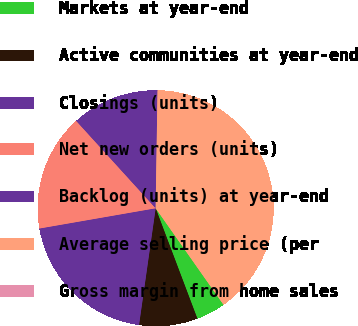Convert chart to OTSL. <chart><loc_0><loc_0><loc_500><loc_500><pie_chart><fcel>Markets at year-end<fcel>Active communities at year-end<fcel>Closings (units)<fcel>Net new orders (units)<fcel>Backlog (units) at year-end<fcel>Average selling price (per<fcel>Gross margin from home sales<nl><fcel>4.0%<fcel>8.0%<fcel>20.0%<fcel>16.0%<fcel>12.0%<fcel>39.99%<fcel>0.0%<nl></chart> 